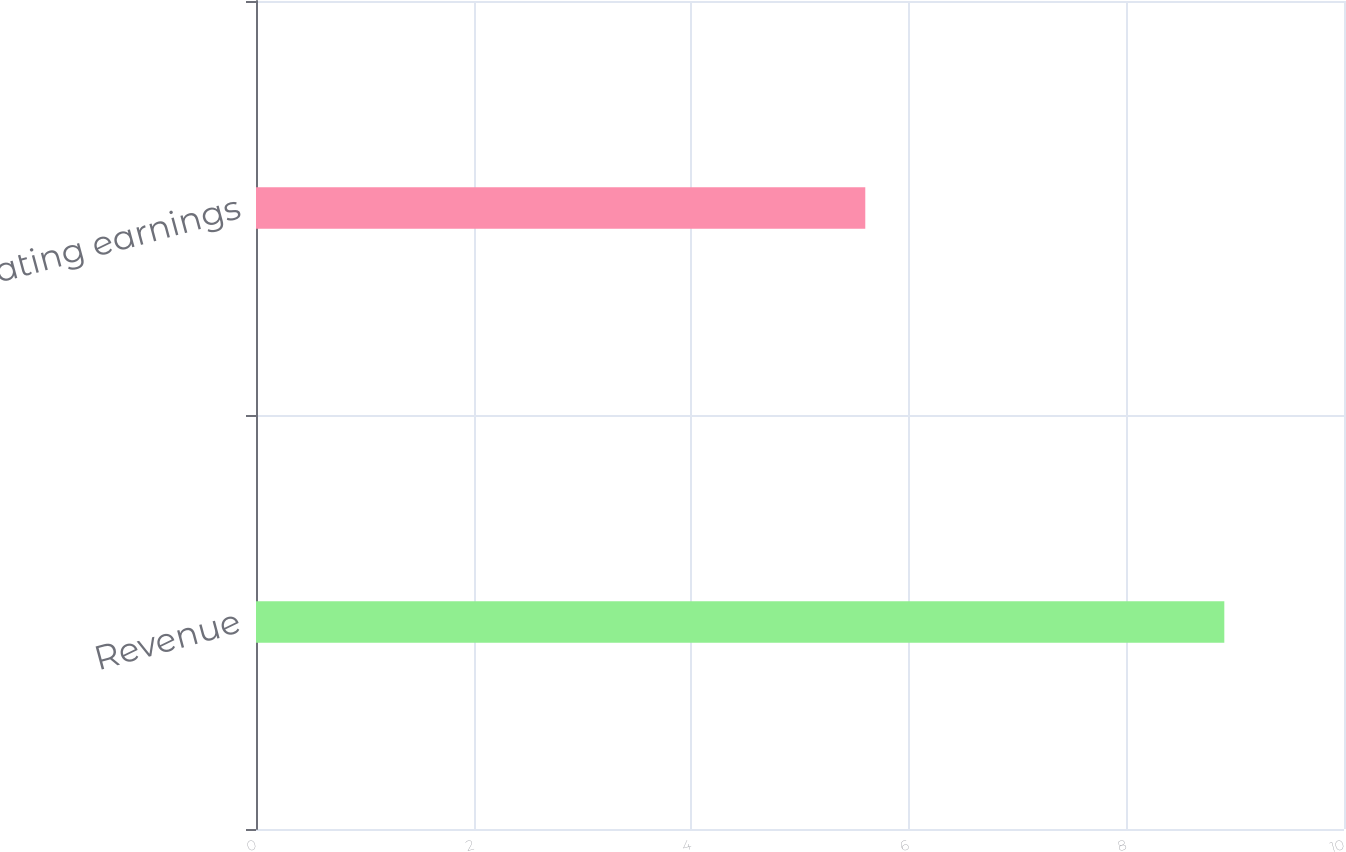Convert chart. <chart><loc_0><loc_0><loc_500><loc_500><bar_chart><fcel>Revenue<fcel>Operating earnings<nl><fcel>8.9<fcel>5.6<nl></chart> 